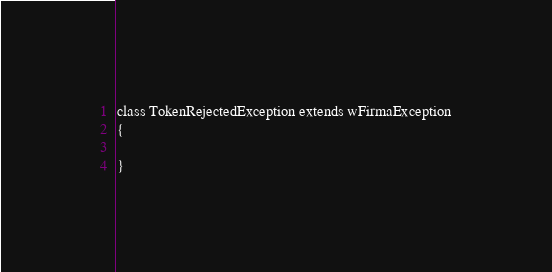Convert code to text. <code><loc_0><loc_0><loc_500><loc_500><_PHP_>class TokenRejectedException extends wFirmaException
{

}
</code> 